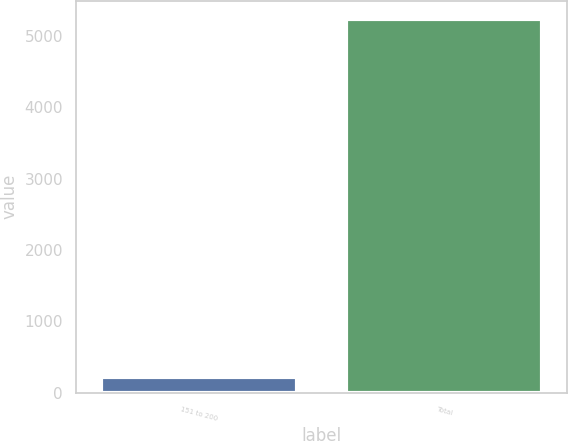Convert chart. <chart><loc_0><loc_0><loc_500><loc_500><bar_chart><fcel>151 to 200<fcel>Total<nl><fcel>221.7<fcel>5230.7<nl></chart> 